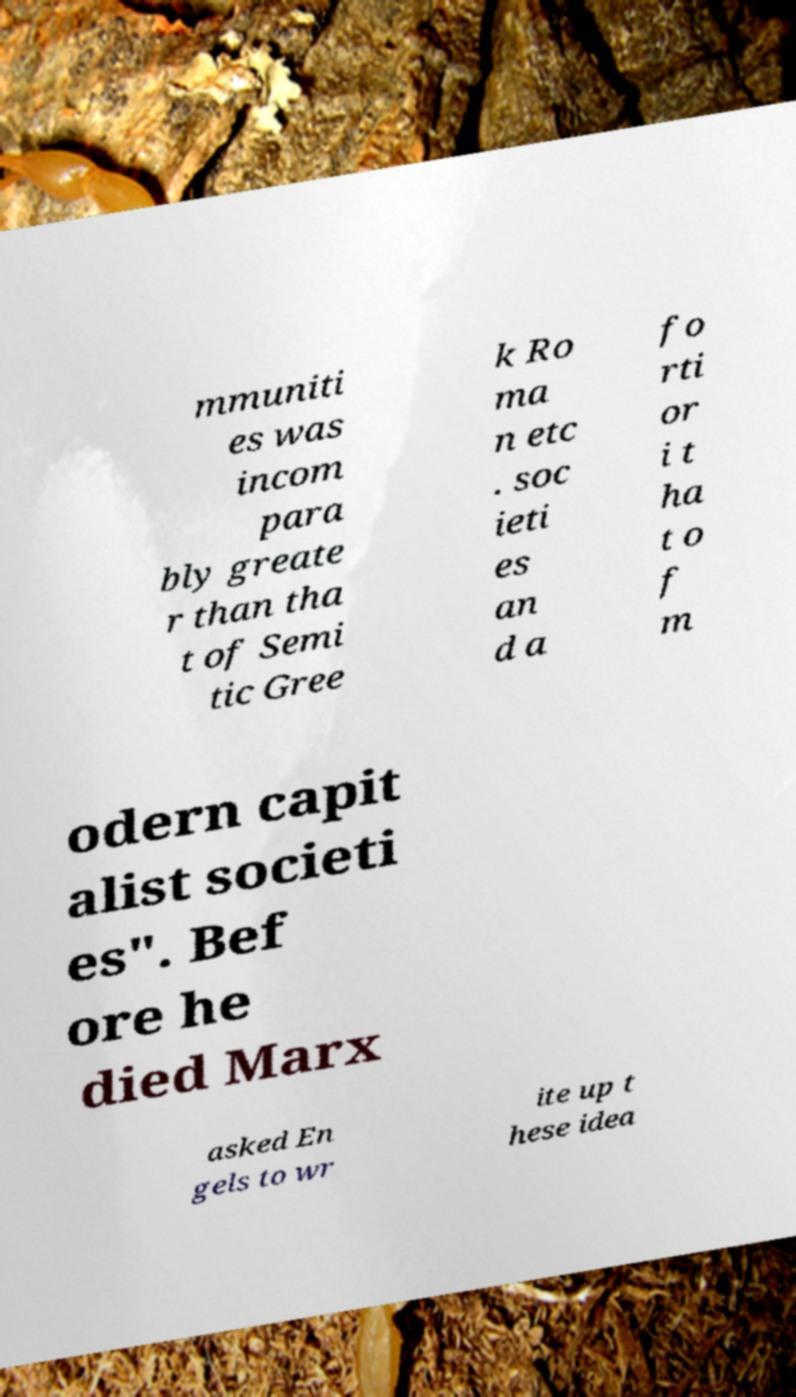I need the written content from this picture converted into text. Can you do that? mmuniti es was incom para bly greate r than tha t of Semi tic Gree k Ro ma n etc . soc ieti es an d a fo rti or i t ha t o f m odern capit alist societi es". Bef ore he died Marx asked En gels to wr ite up t hese idea 